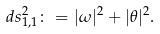Convert formula to latex. <formula><loc_0><loc_0><loc_500><loc_500>d s ^ { 2 } _ { 1 , 1 } \colon = | \omega | ^ { 2 } + | \theta | ^ { 2 } .</formula> 